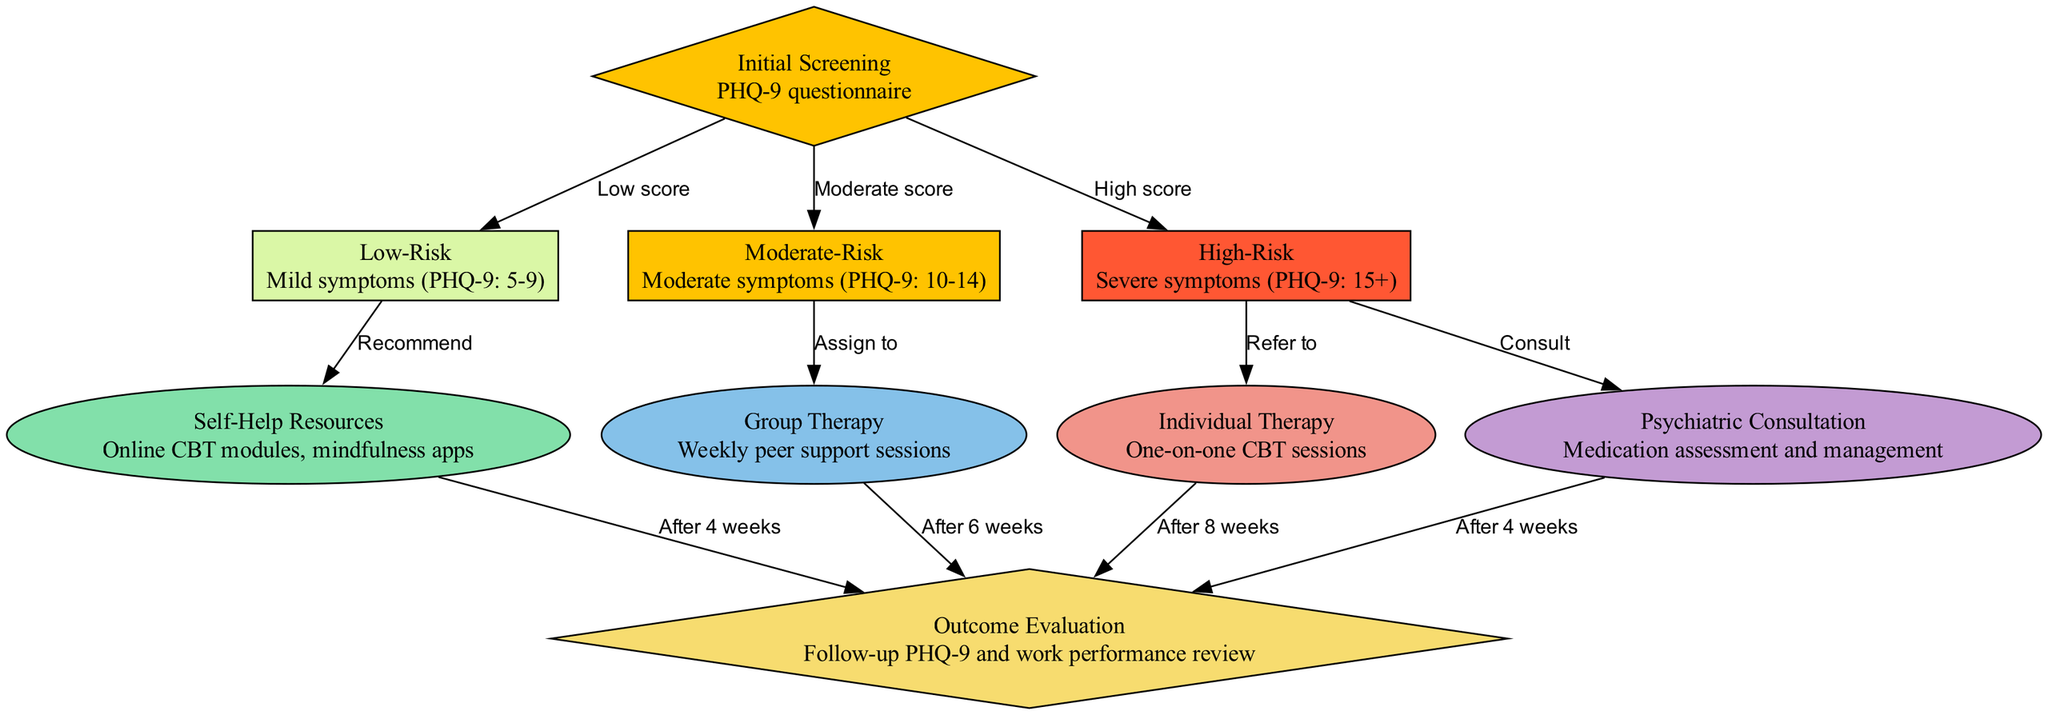What is the first step in the clinical pathway? The first step, as indicated by the "Initial Screening" node, is to conduct the PHQ-9 questionnaire. This is the starting point for assessing the risk levels of depression among healthcare workers.
Answer: Initial Screening How many risk levels are identified in the diagram? The diagram presents three risk levels: Low-Risk, Moderate-Risk, and High-Risk. These levels are determined based on the scores from the initial screening.
Answer: Three What resource is recommended for low-risk individuals? For low-risk individuals, the diagram illustrates that "Self-Help Resources" are recommended after the initial screening. This suggests the use of online CBT modules and mindfulness apps.
Answer: Self-Help Resources What is the action taken for individuals identified as high-risk? High-risk individuals are referred to "Individual Therapy" and may also have a "Psychiatric Consultation" for medication assessment and management according to the nodes in the diagram.
Answer: Refer to Individual Therapy; Consult What is the follow-up period for outcome evaluation after group therapy? After "Group Therapy," the follow-up for outcome evaluation occurs after six weeks, as indicated in the edge between these two nodes.
Answer: After 6 weeks If someone scores 12 on the PHQ-9, what would be the next step? A score of 12 indicates "Moderate symptoms," so the next step as per the diagram would be "Assign to Group Therapy." This follows from the relationships defined for moderate-risk individuals.
Answer: Assign to Group Therapy What is the purpose of the outcome evaluation stage? The "Outcome Evaluation" stage is used to assess treatment effectiveness through a follow-up PHQ-9 and work performance review. This helps determine if the individuals have improved after their respective treatments.
Answer: Assess treatment effectiveness Which node has the description related to online CBT modules? The node labeled "Self-Help Resources" includes descriptions of online CBT modules as one of the resources available for individuals with low-level symptoms.
Answer: Self-Help Resources What does the edge labeled "High score" connect to in the diagram? The "High score" edge connects the "Initial Screening" node with the "High-Risk" node, indicating the pathway for individuals who score 15 or higher on the PHQ-9 questionnaire.
Answer: Connects to High-Risk How long is the follow-up for outcome evaluation after individual therapy? After "Individual Therapy," the follow-up for outcome evaluation occurs after eight weeks, according to the edge connecting these two nodes.
Answer: After 8 weeks 